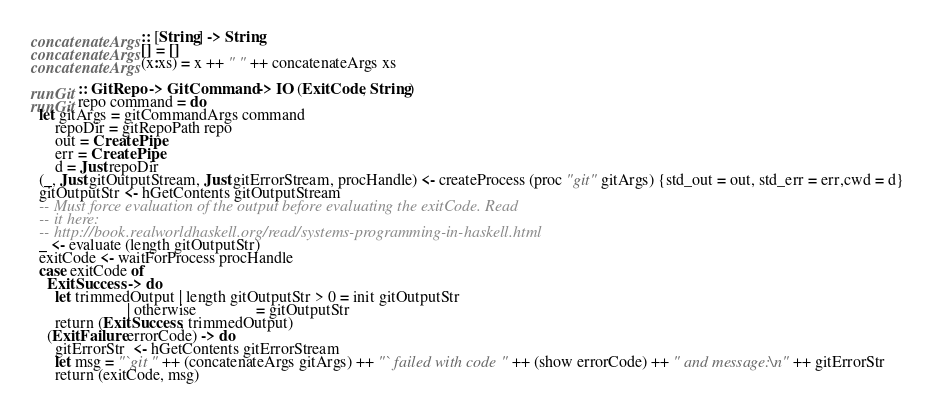<code> <loc_0><loc_0><loc_500><loc_500><_Haskell_>
concatenateArgs :: [String] -> String
concatenateArgs [] = []
concatenateArgs (x:xs) = x ++ " " ++ concatenateArgs xs

runGit :: GitRepo -> GitCommand -> IO (ExitCode, String)
runGit repo command = do
  let gitArgs = gitCommandArgs command
      repoDir = gitRepoPath repo
      out = CreatePipe
      err = CreatePipe
      d = Just repoDir
  (_, Just gitOutputStream, Just gitErrorStream, procHandle) <- createProcess (proc "git" gitArgs) {std_out = out, std_err = err,cwd = d}
  gitOutputStr <- hGetContents gitOutputStream
  -- Must force evaluation of the output before evaluating the exitCode. Read
  -- it here:
  -- http://book.realworldhaskell.org/read/systems-programming-in-haskell.html
  _ <- evaluate (length gitOutputStr)
  exitCode <- waitForProcess procHandle
  case exitCode of
    ExitSuccess -> do
      let trimmedOutput | length gitOutputStr > 0 = init gitOutputStr
                        | otherwise               = gitOutputStr
      return (ExitSuccess, trimmedOutput)
    (ExitFailure errorCode) -> do
      gitErrorStr  <- hGetContents gitErrorStream
      let msg = "`git " ++ (concatenateArgs gitArgs) ++ "` failed with code " ++ (show errorCode) ++ " and message:\n" ++ gitErrorStr
      return (exitCode, msg)
</code> 